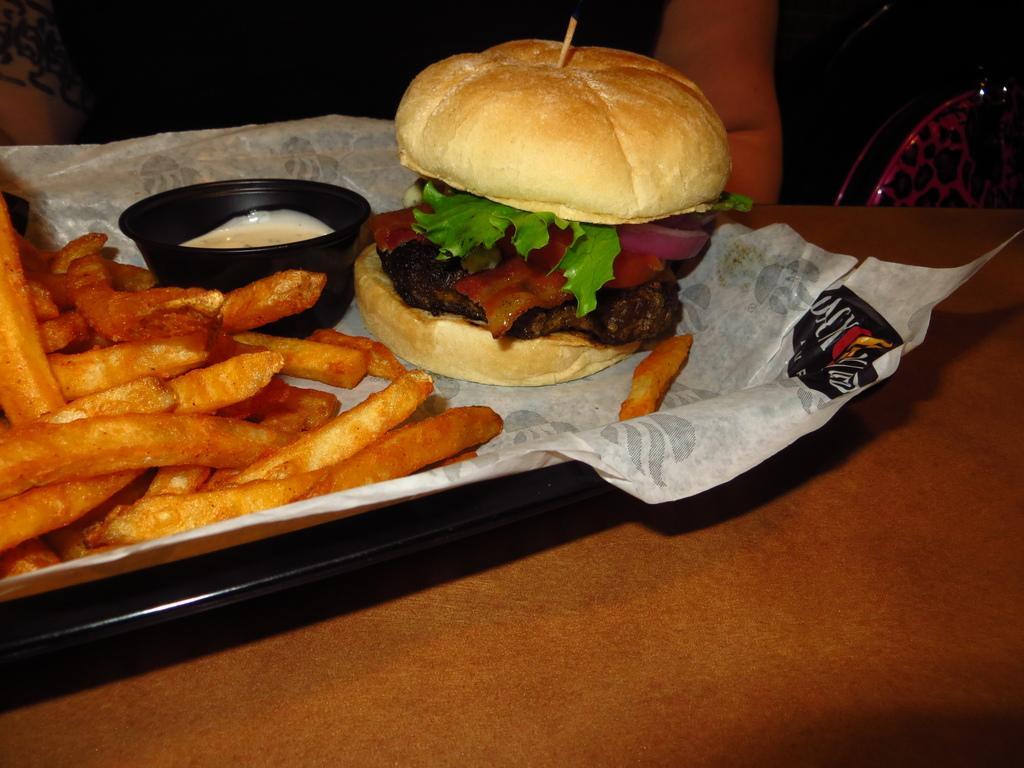Could you give a brief overview of what you see in this image? In this image there is a table, on that table there is a plate, in that place there are food items. 